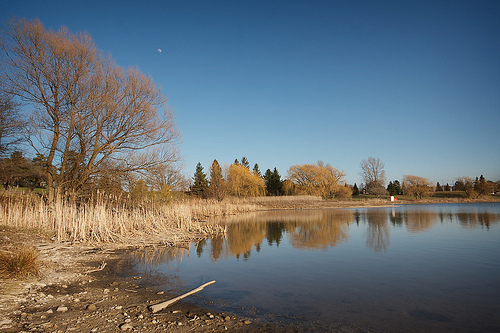<image>
Is there a water behind the tree? No. The water is not behind the tree. From this viewpoint, the water appears to be positioned elsewhere in the scene. 